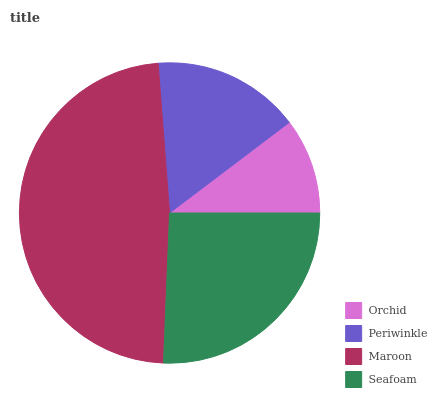Is Orchid the minimum?
Answer yes or no. Yes. Is Maroon the maximum?
Answer yes or no. Yes. Is Periwinkle the minimum?
Answer yes or no. No. Is Periwinkle the maximum?
Answer yes or no. No. Is Periwinkle greater than Orchid?
Answer yes or no. Yes. Is Orchid less than Periwinkle?
Answer yes or no. Yes. Is Orchid greater than Periwinkle?
Answer yes or no. No. Is Periwinkle less than Orchid?
Answer yes or no. No. Is Seafoam the high median?
Answer yes or no. Yes. Is Periwinkle the low median?
Answer yes or no. Yes. Is Periwinkle the high median?
Answer yes or no. No. Is Seafoam the low median?
Answer yes or no. No. 